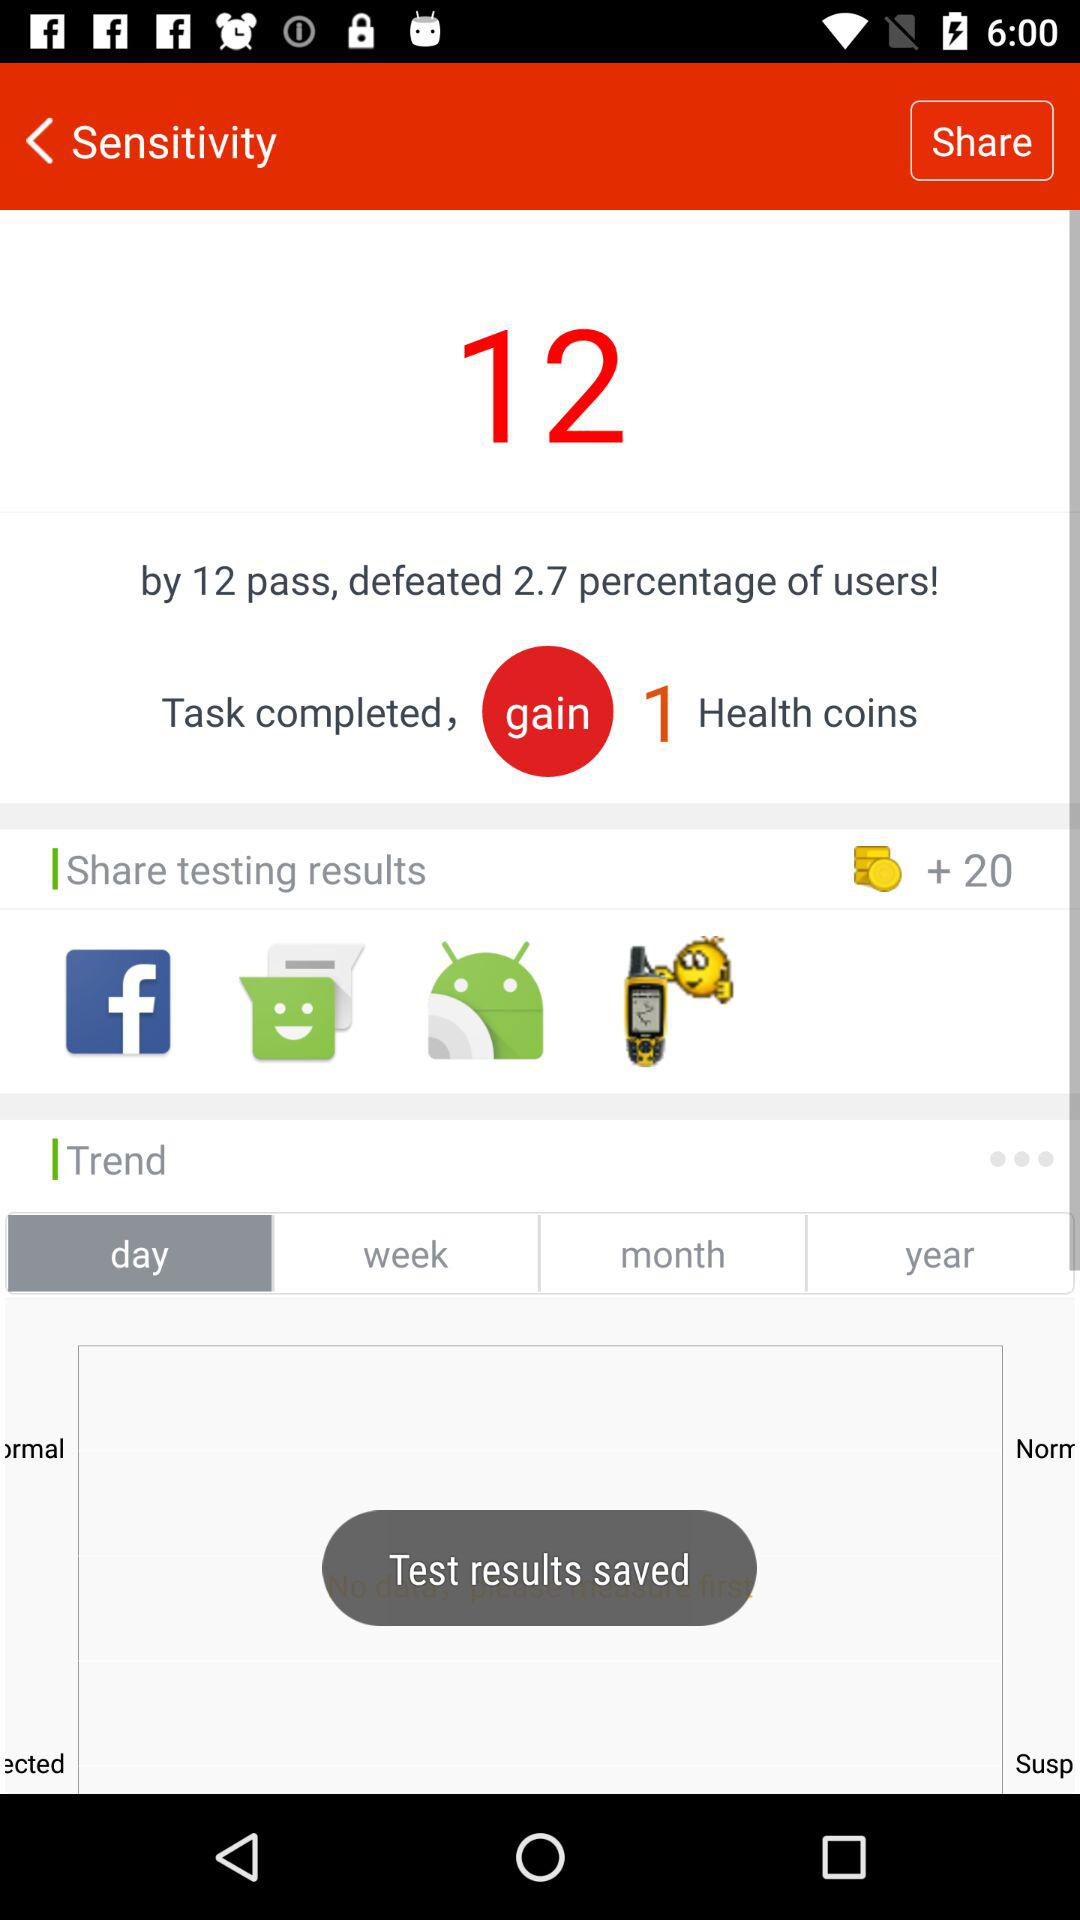What are the options for sharing testing results? The options for sharing testing results are "Facebook", "Messaging", "Android Beam" and "Fake GPS - Search location". 